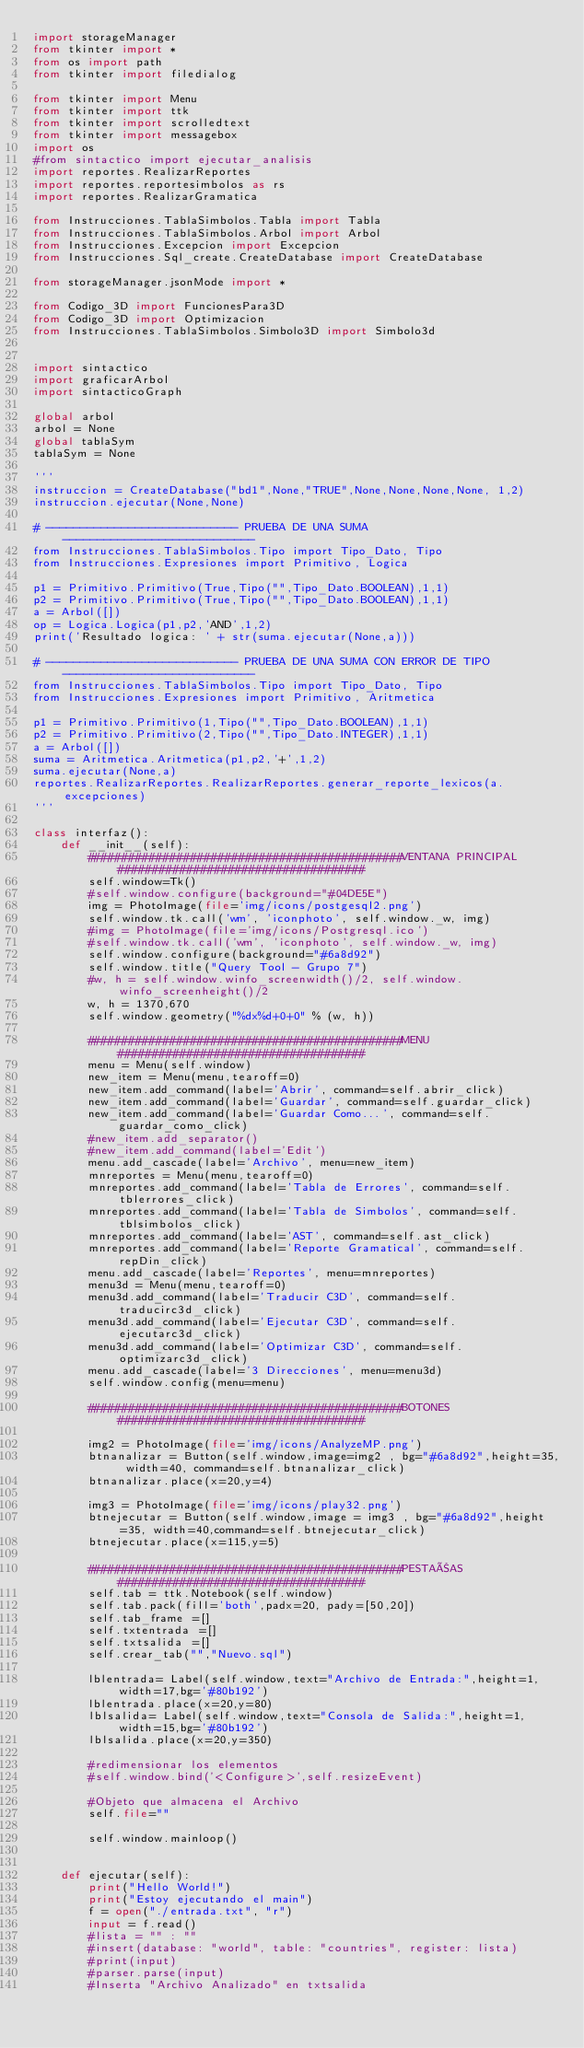Convert code to text. <code><loc_0><loc_0><loc_500><loc_500><_Python_>import storageManager
from tkinter import *
from os import path
from tkinter import filedialog

from tkinter import Menu
from tkinter import ttk
from tkinter import scrolledtext
from tkinter import messagebox
import os
#from sintactico import ejecutar_analisis
import reportes.RealizarReportes
import reportes.reportesimbolos as rs
import reportes.RealizarGramatica

from Instrucciones.TablaSimbolos.Tabla import Tabla
from Instrucciones.TablaSimbolos.Arbol import Arbol
from Instrucciones.Excepcion import Excepcion
from Instrucciones.Sql_create.CreateDatabase import CreateDatabase

from storageManager.jsonMode import *

from Codigo_3D import FuncionesPara3D
from Codigo_3D import Optimizacion
from Instrucciones.TablaSimbolos.Simbolo3D import Simbolo3d


import sintactico
import graficarArbol
import sintacticoGraph

global arbol
arbol = None
global tablaSym
tablaSym = None

'''
instruccion = CreateDatabase("bd1",None,"TRUE",None,None,None,None, 1,2)
instruccion.ejecutar(None,None)

# ---------------------------- PRUEBA DE UNA SUMA  ----------------------------
from Instrucciones.TablaSimbolos.Tipo import Tipo_Dato, Tipo
from Instrucciones.Expresiones import Primitivo, Logica

p1 = Primitivo.Primitivo(True,Tipo("",Tipo_Dato.BOOLEAN),1,1)
p2 = Primitivo.Primitivo(True,Tipo("",Tipo_Dato.BOOLEAN),1,1)
a = Arbol([])
op = Logica.Logica(p1,p2,'AND',1,2)
print('Resultado logica: ' + str(suma.ejecutar(None,a)))

# ---------------------------- PRUEBA DE UNA SUMA CON ERROR DE TIPO ----------------------------
from Instrucciones.TablaSimbolos.Tipo import Tipo_Dato, Tipo
from Instrucciones.Expresiones import Primitivo, Aritmetica

p1 = Primitivo.Primitivo(1,Tipo("",Tipo_Dato.BOOLEAN),1,1)
p2 = Primitivo.Primitivo(2,Tipo("",Tipo_Dato.INTEGER),1,1)
a = Arbol([])
suma = Aritmetica.Aritmetica(p1,p2,'+',1,2)
suma.ejecutar(None,a)
reportes.RealizarReportes.RealizarReportes.generar_reporte_lexicos(a.excepciones)
'''

class interfaz():
    def __init__(self):
        ##############################################VENTANA PRINCIPAL####################################
        self.window=Tk()
        #self.window.configure(background="#04DE5E")
        img = PhotoImage(file='img/icons/postgesql2.png')
        self.window.tk.call('wm', 'iconphoto', self.window._w, img)
        #img = PhotoImage(file='img/icons/Postgresql.ico')
        #self.window.tk.call('wm', 'iconphoto', self.window._w, img)
        self.window.configure(background="#6a8d92")
        self.window.title("Query Tool - Grupo 7")
        #w, h = self.window.winfo_screenwidth()/2, self.window.winfo_screenheight()/2
        w, h = 1370,670
        self.window.geometry("%dx%d+0+0" % (w, h))
        
        ##############################################MENU####################################
        menu = Menu(self.window)
        new_item = Menu(menu,tearoff=0)
        new_item.add_command(label='Abrir', command=self.abrir_click)
        new_item.add_command(label='Guardar', command=self.guardar_click)
        new_item.add_command(label='Guardar Como...', command=self.guardar_como_click)
        #new_item.add_separator()
        #new_item.add_command(label='Edit')
        menu.add_cascade(label='Archivo', menu=new_item)
        mnreportes = Menu(menu,tearoff=0)
        mnreportes.add_command(label='Tabla de Errores', command=self.tblerrores_click)
        mnreportes.add_command(label='Tabla de Simbolos', command=self.tblsimbolos_click)
        mnreportes.add_command(label='AST', command=self.ast_click)
        mnreportes.add_command(label='Reporte Gramatical', command=self.repDin_click)
        menu.add_cascade(label='Reportes', menu=mnreportes)
        menu3d = Menu(menu,tearoff=0)
        menu3d.add_command(label='Traducir C3D', command=self.traducirc3d_click)
        menu3d.add_command(label='Ejecutar C3D', command=self.ejecutarc3d_click)
        menu3d.add_command(label='Optimizar C3D', command=self.optimizarc3d_click)
        menu.add_cascade(label='3 Direcciones', menu=menu3d)
        self.window.config(menu=menu)

        ##############################################BOTONES####################################
        
        img2 = PhotoImage(file='img/icons/AnalyzeMP.png')
        btnanalizar = Button(self.window,image=img2 , bg="#6a8d92",height=35, width=40, command=self.btnanalizar_click)
        btnanalizar.place(x=20,y=4)

        img3 = PhotoImage(file='img/icons/play32.png')
        btnejecutar = Button(self.window,image = img3 , bg="#6a8d92",height=35, width=40,command=self.btnejecutar_click)
        btnejecutar.place(x=115,y=5)

        ##############################################PESTAÑAS####################################
        self.tab = ttk.Notebook(self.window)
        self.tab.pack(fill='both',padx=20, pady=[50,20])
        self.tab_frame =[]
        self.txtentrada =[]
        self.txtsalida =[]
        self.crear_tab("","Nuevo.sql")
        
        lblentrada= Label(self.window,text="Archivo de Entrada:",height=1, width=17,bg='#80b192')
        lblentrada.place(x=20,y=80)
        lblsalida= Label(self.window,text="Consola de Salida:",height=1, width=15,bg='#80b192')
        lblsalida.place(x=20,y=350)

        #redimensionar los elementos
        #self.window.bind('<Configure>',self.resizeEvent)

        #Objeto que almacena el Archivo
        self.file=""

        self.window.mainloop()
    

    def ejecutar(self):
        print("Hello World!")
        print("Estoy ejecutando el main")
        f = open("./entrada.txt", "r")
        input = f.read()
        #lista = "" : ""
        #insert(database: "world", table: "countries", register: lista) 
        #print(input)
        #parser.parse(input)
        #Inserta "Archivo Analizado" en txtsalida
        
        </code> 